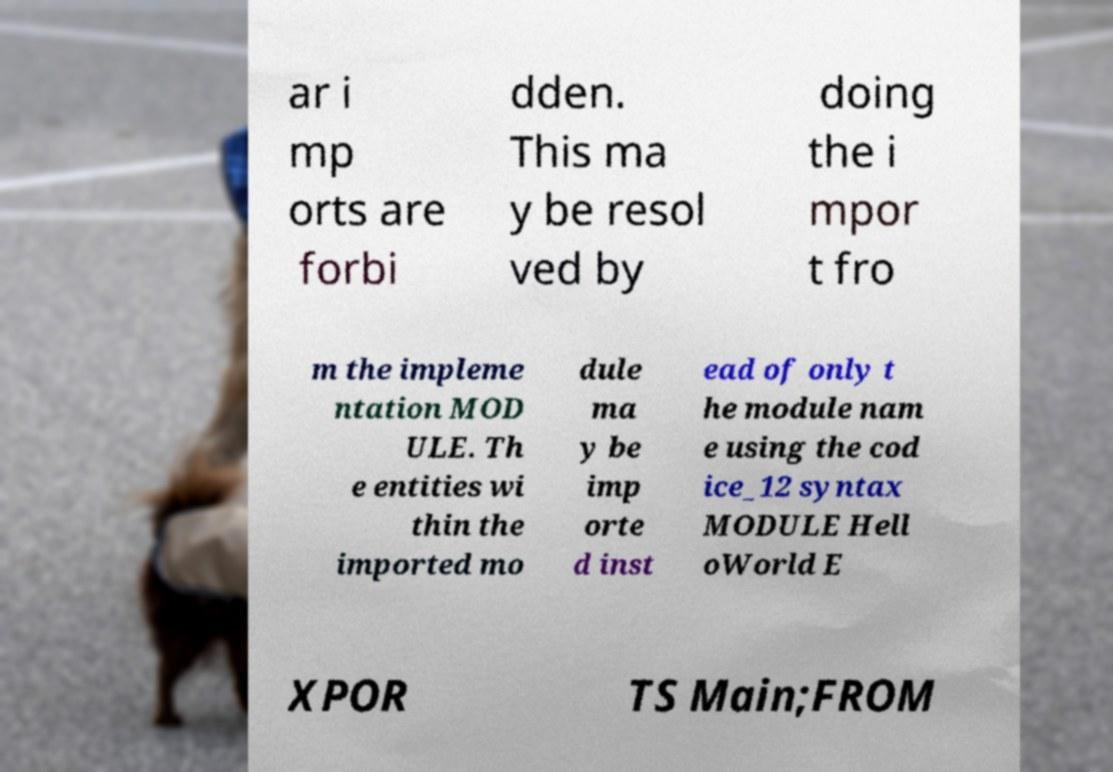Can you accurately transcribe the text from the provided image for me? ar i mp orts are forbi dden. This ma y be resol ved by doing the i mpor t fro m the impleme ntation MOD ULE. Th e entities wi thin the imported mo dule ma y be imp orte d inst ead of only t he module nam e using the cod ice_12 syntax MODULE Hell oWorld E XPOR TS Main;FROM 